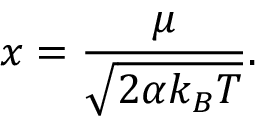<formula> <loc_0><loc_0><loc_500><loc_500>x = \frac { \mu } { \sqrt { 2 \alpha k _ { B } T } } .</formula> 